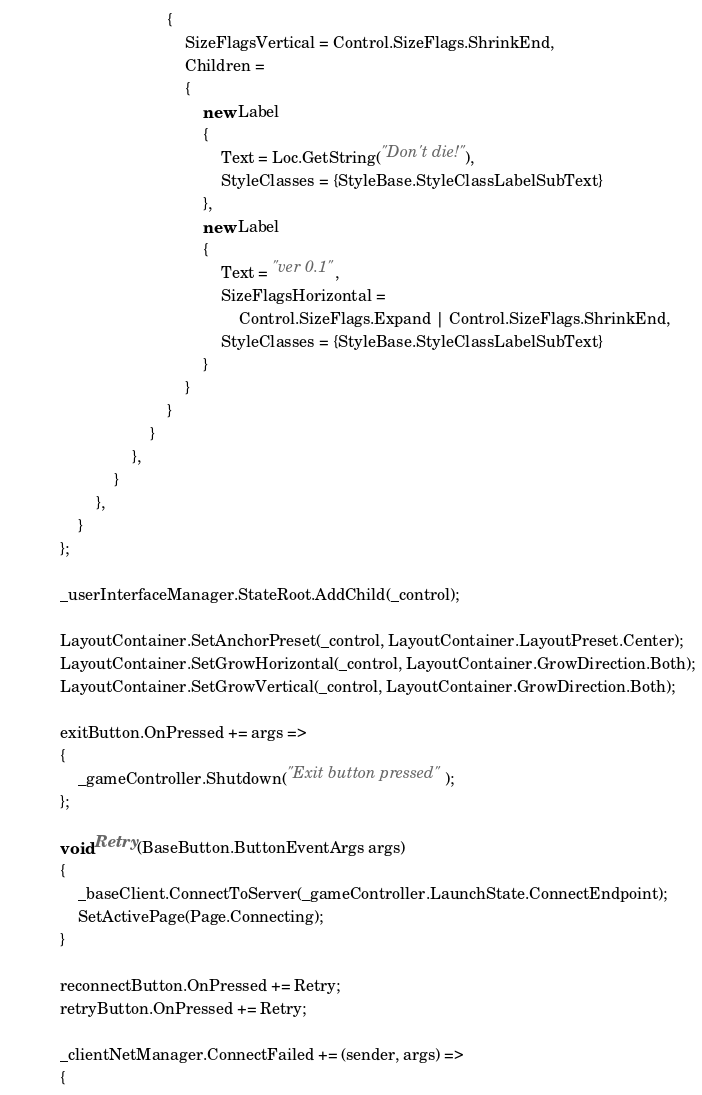<code> <loc_0><loc_0><loc_500><loc_500><_C#_>                                    {
                                        SizeFlagsVertical = Control.SizeFlags.ShrinkEnd,
                                        Children =
                                        {
                                            new Label
                                            {
                                                Text = Loc.GetString("Don't die!"),
                                                StyleClasses = {StyleBase.StyleClassLabelSubText}
                                            },
                                            new Label
                                            {
                                                Text = "ver 0.1",
                                                SizeFlagsHorizontal =
                                                    Control.SizeFlags.Expand | Control.SizeFlags.ShrinkEnd,
                                                StyleClasses = {StyleBase.StyleClassLabelSubText}
                                            }
                                        }
                                    }
                                }
                            },
                        }
                    },
                }
            };

            _userInterfaceManager.StateRoot.AddChild(_control);

            LayoutContainer.SetAnchorPreset(_control, LayoutContainer.LayoutPreset.Center);
            LayoutContainer.SetGrowHorizontal(_control, LayoutContainer.GrowDirection.Both);
            LayoutContainer.SetGrowVertical(_control, LayoutContainer.GrowDirection.Both);

            exitButton.OnPressed += args =>
            {
                _gameController.Shutdown("Exit button pressed");
            };

            void Retry(BaseButton.ButtonEventArgs args)
            {
                _baseClient.ConnectToServer(_gameController.LaunchState.ConnectEndpoint);
                SetActivePage(Page.Connecting);
            }

            reconnectButton.OnPressed += Retry;
            retryButton.OnPressed += Retry;

            _clientNetManager.ConnectFailed += (sender, args) =>
            {</code> 